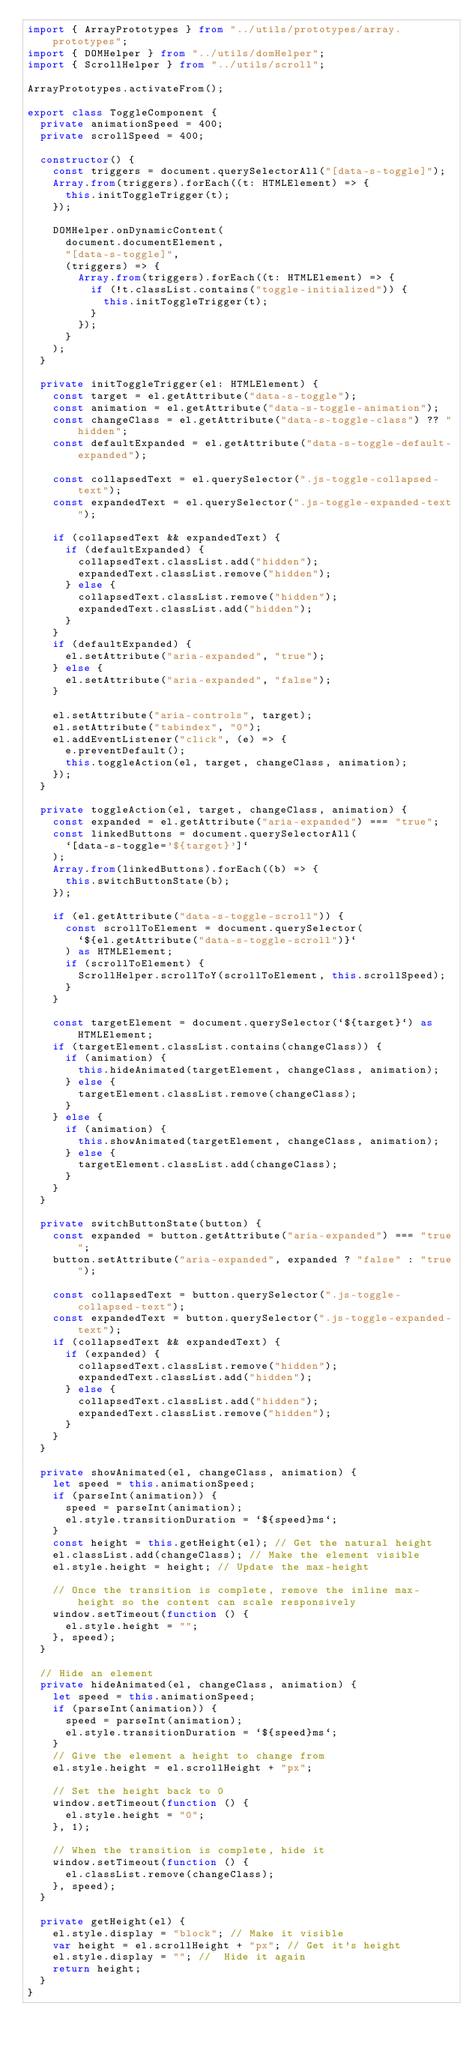<code> <loc_0><loc_0><loc_500><loc_500><_TypeScript_>import { ArrayPrototypes } from "../utils/prototypes/array.prototypes";
import { DOMHelper } from "../utils/domHelper";
import { ScrollHelper } from "../utils/scroll";

ArrayPrototypes.activateFrom();

export class ToggleComponent {
  private animationSpeed = 400;
  private scrollSpeed = 400;

  constructor() {
    const triggers = document.querySelectorAll("[data-s-toggle]");
    Array.from(triggers).forEach((t: HTMLElement) => {
      this.initToggleTrigger(t);
    });

    DOMHelper.onDynamicContent(
      document.documentElement,
      "[data-s-toggle]",
      (triggers) => {
        Array.from(triggers).forEach((t: HTMLElement) => {
          if (!t.classList.contains("toggle-initialized")) {
            this.initToggleTrigger(t);
          }
        });
      }
    );
  }

  private initToggleTrigger(el: HTMLElement) {
    const target = el.getAttribute("data-s-toggle");
    const animation = el.getAttribute("data-s-toggle-animation");
    const changeClass = el.getAttribute("data-s-toggle-class") ?? "hidden";
    const defaultExpanded = el.getAttribute("data-s-toggle-default-expanded");

    const collapsedText = el.querySelector(".js-toggle-collapsed-text");
    const expandedText = el.querySelector(".js-toggle-expanded-text");

    if (collapsedText && expandedText) {
      if (defaultExpanded) {
        collapsedText.classList.add("hidden");
        expandedText.classList.remove("hidden");
      } else {
        collapsedText.classList.remove("hidden");
        expandedText.classList.add("hidden");
      }
    }
    if (defaultExpanded) {
      el.setAttribute("aria-expanded", "true");
    } else {
      el.setAttribute("aria-expanded", "false");
    }

    el.setAttribute("aria-controls", target);
    el.setAttribute("tabindex", "0");
    el.addEventListener("click", (e) => {
      e.preventDefault();
      this.toggleAction(el, target, changeClass, animation);
    });
  }

  private toggleAction(el, target, changeClass, animation) {
    const expanded = el.getAttribute("aria-expanded") === "true";
    const linkedButtons = document.querySelectorAll(
      `[data-s-toggle='${target}']`
    );
    Array.from(linkedButtons).forEach((b) => {
      this.switchButtonState(b);
    });

    if (el.getAttribute("data-s-toggle-scroll")) {
      const scrollToElement = document.querySelector(
        `${el.getAttribute("data-s-toggle-scroll")}`
      ) as HTMLElement;
      if (scrollToElement) {
        ScrollHelper.scrollToY(scrollToElement, this.scrollSpeed);
      }
    }

    const targetElement = document.querySelector(`${target}`) as HTMLElement;
    if (targetElement.classList.contains(changeClass)) {
      if (animation) {
        this.hideAnimated(targetElement, changeClass, animation);
      } else {
        targetElement.classList.remove(changeClass);
      }
    } else {
      if (animation) {
        this.showAnimated(targetElement, changeClass, animation);
      } else {
        targetElement.classList.add(changeClass);
      }
    }
  }

  private switchButtonState(button) {
    const expanded = button.getAttribute("aria-expanded") === "true";
    button.setAttribute("aria-expanded", expanded ? "false" : "true");

    const collapsedText = button.querySelector(".js-toggle-collapsed-text");
    const expandedText = button.querySelector(".js-toggle-expanded-text");
    if (collapsedText && expandedText) {
      if (expanded) {
        collapsedText.classList.remove("hidden");
        expandedText.classList.add("hidden");
      } else {
        collapsedText.classList.add("hidden");
        expandedText.classList.remove("hidden");
      }
    }
  }

  private showAnimated(el, changeClass, animation) {
    let speed = this.animationSpeed;
    if (parseInt(animation)) {
      speed = parseInt(animation);
      el.style.transitionDuration = `${speed}ms`;
    }
    const height = this.getHeight(el); // Get the natural height
    el.classList.add(changeClass); // Make the element visible
    el.style.height = height; // Update the max-height

    // Once the transition is complete, remove the inline max-height so the content can scale responsively
    window.setTimeout(function () {
      el.style.height = "";
    }, speed);
  }

  // Hide an element
  private hideAnimated(el, changeClass, animation) {
    let speed = this.animationSpeed;
    if (parseInt(animation)) {
      speed = parseInt(animation);
      el.style.transitionDuration = `${speed}ms`;
    }
    // Give the element a height to change from
    el.style.height = el.scrollHeight + "px";

    // Set the height back to 0
    window.setTimeout(function () {
      el.style.height = "0";
    }, 1);

    // When the transition is complete, hide it
    window.setTimeout(function () {
      el.classList.remove(changeClass);
    }, speed);
  }

  private getHeight(el) {
    el.style.display = "block"; // Make it visible
    var height = el.scrollHeight + "px"; // Get it's height
    el.style.display = ""; //  Hide it again
    return height;
  }
}
</code> 